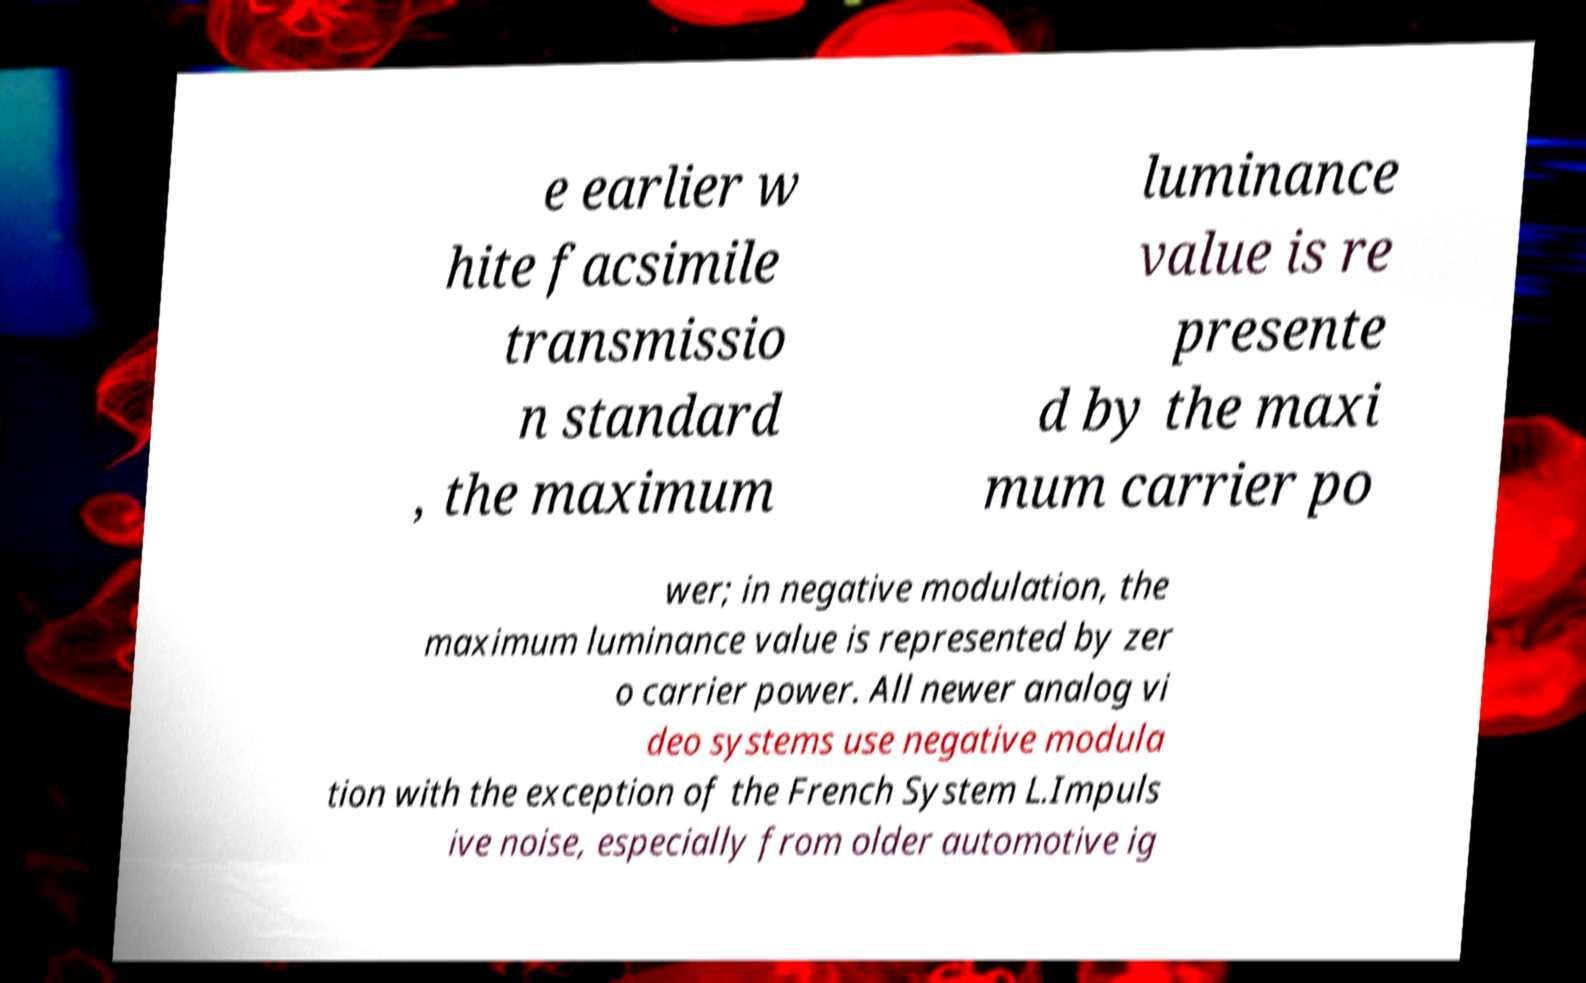Can you read and provide the text displayed in the image?This photo seems to have some interesting text. Can you extract and type it out for me? e earlier w hite facsimile transmissio n standard , the maximum luminance value is re presente d by the maxi mum carrier po wer; in negative modulation, the maximum luminance value is represented by zer o carrier power. All newer analog vi deo systems use negative modula tion with the exception of the French System L.Impuls ive noise, especially from older automotive ig 